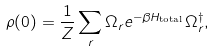<formula> <loc_0><loc_0><loc_500><loc_500>\rho ( 0 ) = \frac { 1 } { Z } \sum _ { r } \Omega _ { r } e ^ { - \beta H _ { \text {total} } } \Omega _ { r } ^ { \dagger } ,</formula> 